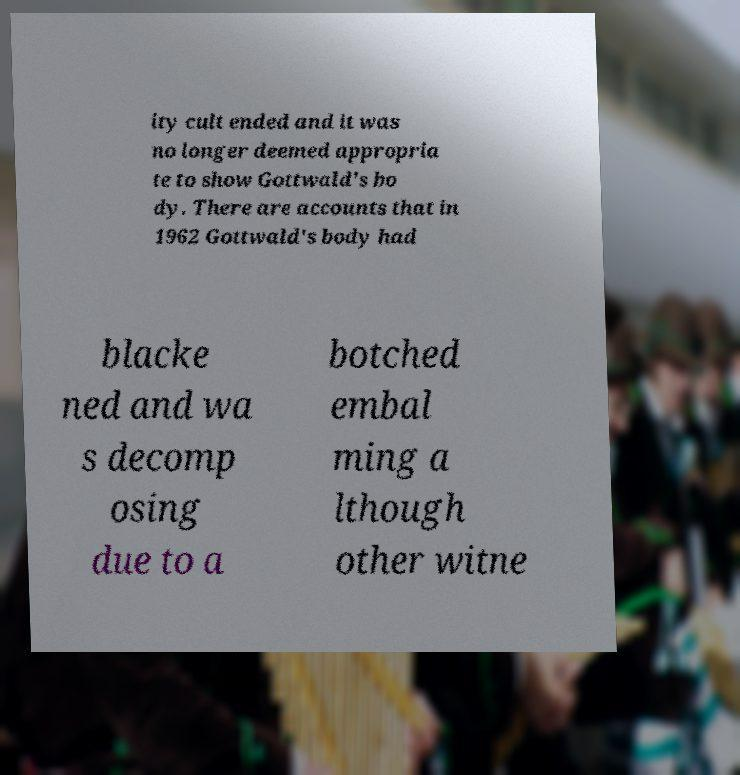Can you read and provide the text displayed in the image?This photo seems to have some interesting text. Can you extract and type it out for me? ity cult ended and it was no longer deemed appropria te to show Gottwald's bo dy. There are accounts that in 1962 Gottwald's body had blacke ned and wa s decomp osing due to a botched embal ming a lthough other witne 